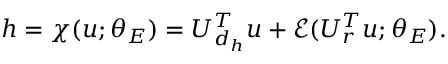Convert formula to latex. <formula><loc_0><loc_0><loc_500><loc_500>h = \chi ( u ; \theta _ { E } ) = U _ { d _ { h } } ^ { T } u + \mathcal { E } ( U _ { r } ^ { T } u ; \theta _ { E } ) .</formula> 